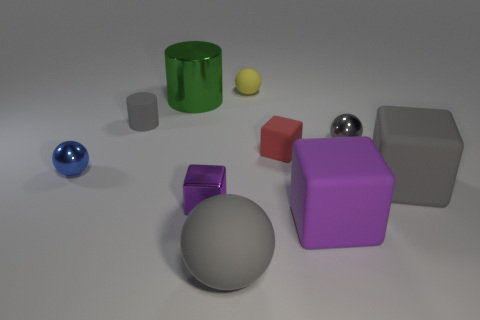The metal thing that is the same color as the tiny cylinder is what size?
Your answer should be very brief. Small. There is a purple thing that is the same material as the blue sphere; what size is it?
Your answer should be compact. Small. What number of things are big cubes or small gray objects?
Make the answer very short. 4. What color is the object behind the big cylinder?
Keep it short and to the point. Yellow. What size is the gray metallic thing that is the same shape as the yellow object?
Give a very brief answer. Small. What number of things are either things on the left side of the green metal cylinder or big balls that are in front of the shiny block?
Your answer should be very brief. 3. What size is the thing that is in front of the small yellow matte sphere and behind the gray rubber cylinder?
Ensure brevity in your answer.  Large. Does the small yellow rubber object have the same shape as the big gray thing right of the yellow thing?
Your response must be concise. No. What number of things are either small yellow matte objects behind the large green shiny thing or red rubber blocks?
Make the answer very short. 2. Are the tiny gray ball and the small gray thing to the left of the small yellow matte sphere made of the same material?
Your response must be concise. No. 